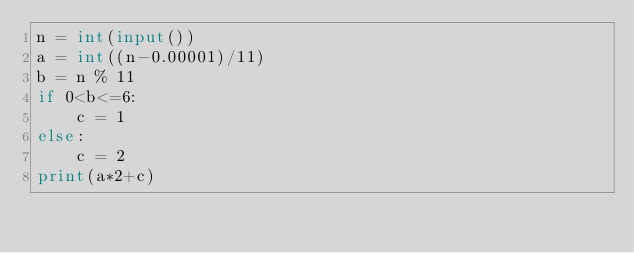<code> <loc_0><loc_0><loc_500><loc_500><_Python_>n = int(input())
a = int((n-0.00001)/11)
b = n % 11
if 0<b<=6:
    c = 1
else:
    c = 2
print(a*2+c)</code> 